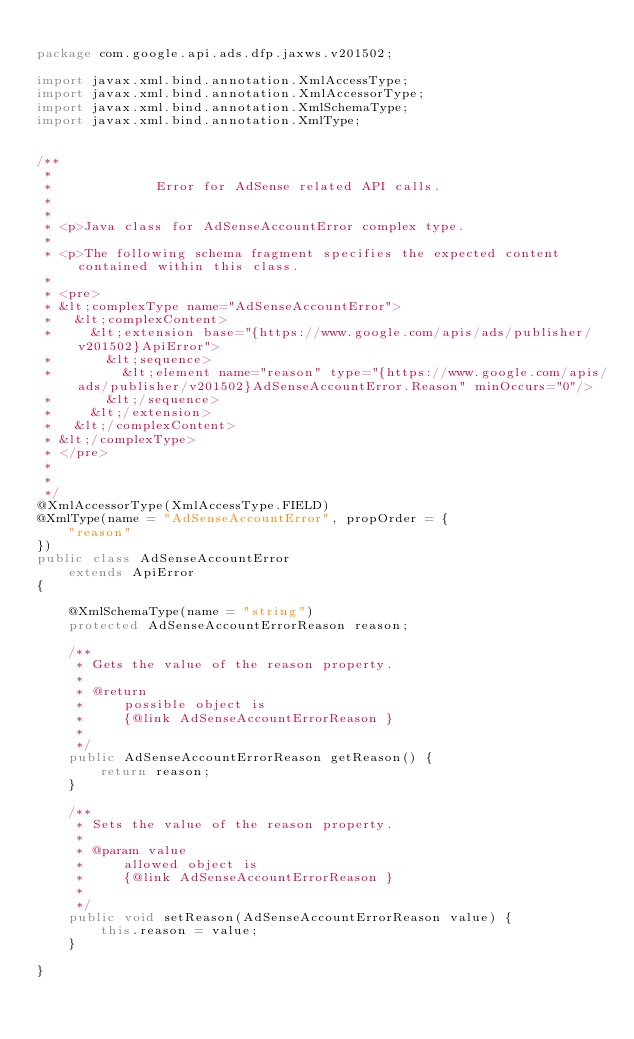Convert code to text. <code><loc_0><loc_0><loc_500><loc_500><_Java_>
package com.google.api.ads.dfp.jaxws.v201502;

import javax.xml.bind.annotation.XmlAccessType;
import javax.xml.bind.annotation.XmlAccessorType;
import javax.xml.bind.annotation.XmlSchemaType;
import javax.xml.bind.annotation.XmlType;


/**
 * 
 *             Error for AdSense related API calls.
 *           
 * 
 * <p>Java class for AdSenseAccountError complex type.
 * 
 * <p>The following schema fragment specifies the expected content contained within this class.
 * 
 * <pre>
 * &lt;complexType name="AdSenseAccountError">
 *   &lt;complexContent>
 *     &lt;extension base="{https://www.google.com/apis/ads/publisher/v201502}ApiError">
 *       &lt;sequence>
 *         &lt;element name="reason" type="{https://www.google.com/apis/ads/publisher/v201502}AdSenseAccountError.Reason" minOccurs="0"/>
 *       &lt;/sequence>
 *     &lt;/extension>
 *   &lt;/complexContent>
 * &lt;/complexType>
 * </pre>
 * 
 * 
 */
@XmlAccessorType(XmlAccessType.FIELD)
@XmlType(name = "AdSenseAccountError", propOrder = {
    "reason"
})
public class AdSenseAccountError
    extends ApiError
{

    @XmlSchemaType(name = "string")
    protected AdSenseAccountErrorReason reason;

    /**
     * Gets the value of the reason property.
     * 
     * @return
     *     possible object is
     *     {@link AdSenseAccountErrorReason }
     *     
     */
    public AdSenseAccountErrorReason getReason() {
        return reason;
    }

    /**
     * Sets the value of the reason property.
     * 
     * @param value
     *     allowed object is
     *     {@link AdSenseAccountErrorReason }
     *     
     */
    public void setReason(AdSenseAccountErrorReason value) {
        this.reason = value;
    }

}
</code> 